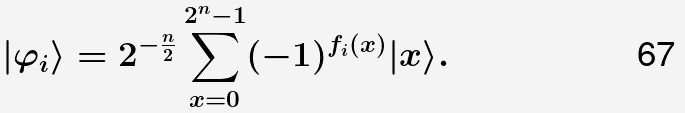Convert formula to latex. <formula><loc_0><loc_0><loc_500><loc_500>| \varphi _ { i } \rangle = 2 ^ { - \frac { n } { 2 } } \sum _ { x = 0 } ^ { 2 ^ { n } - 1 } ( - 1 ) ^ { f _ { i } ( x ) } | x \rangle .</formula> 